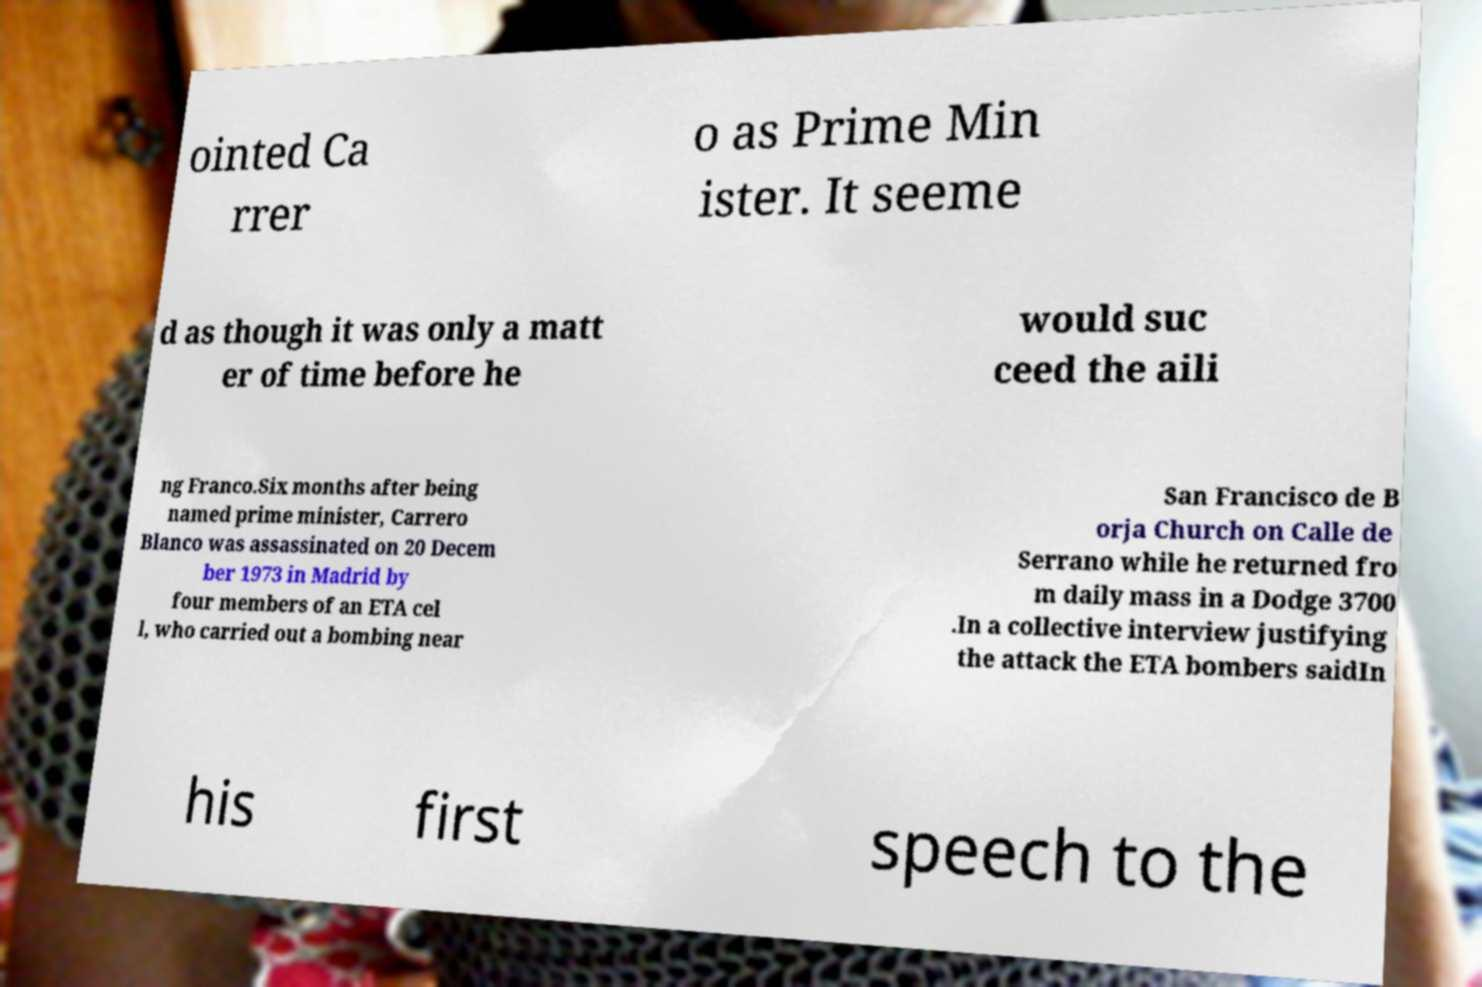Please read and relay the text visible in this image. What does it say? ointed Ca rrer o as Prime Min ister. It seeme d as though it was only a matt er of time before he would suc ceed the aili ng Franco.Six months after being named prime minister, Carrero Blanco was assassinated on 20 Decem ber 1973 in Madrid by four members of an ETA cel l, who carried out a bombing near San Francisco de B orja Church on Calle de Serrano while he returned fro m daily mass in a Dodge 3700 .In a collective interview justifying the attack the ETA bombers saidIn his first speech to the 